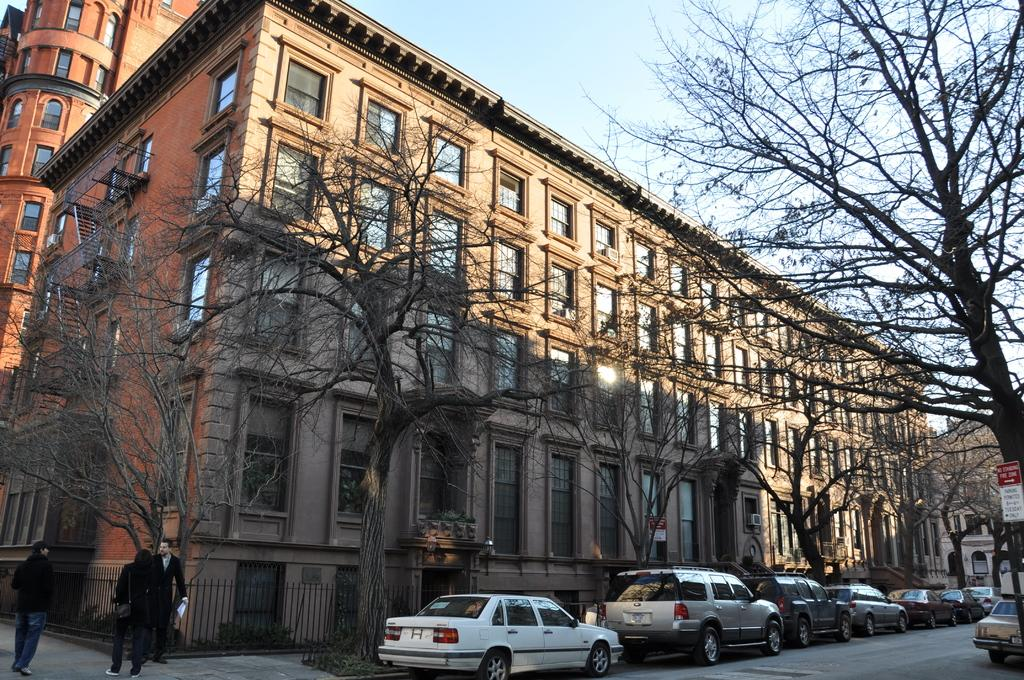How many people are in the image? There are three persons standing in the image. What is blocking the path in the image? Vehicles are parked on the path are blocking it in the image. What type of structure can be seen in the image? There are iron grills in the image. What is the purpose of the board in the image? The purpose of the board in the image is not clear from the facts provided. What type of vegetation is present in the image? Trees are present in the image. What type of structures can be seen in the background of the image? Buildings are visible in the background of the image. What is visible in the sky in the image? The sky is visible in the background of the image. What type of soup is being served in the image? There is no soup present in the image. Can you see a robin perched on the iron grills in the image? There is no robin present in the image. 